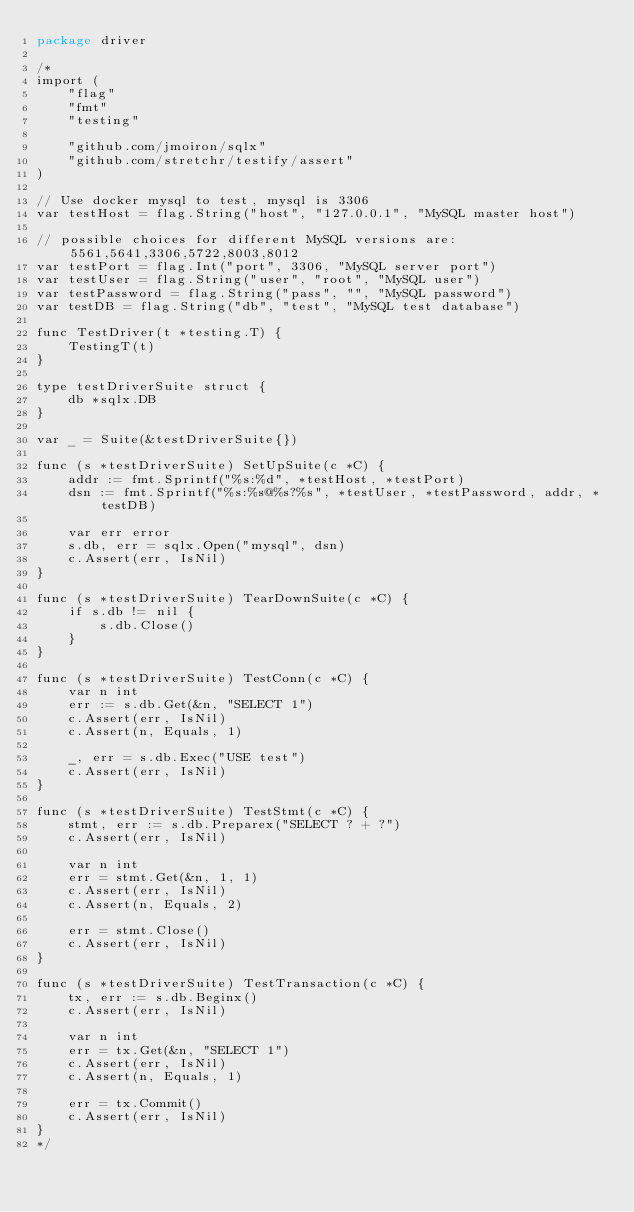Convert code to text. <code><loc_0><loc_0><loc_500><loc_500><_Go_>package driver

/*
import (
	"flag"
	"fmt"
	"testing"

	"github.com/jmoiron/sqlx"
	"github.com/stretchr/testify/assert"
)

// Use docker mysql to test, mysql is 3306
var testHost = flag.String("host", "127.0.0.1", "MySQL master host")

// possible choices for different MySQL versions are: 5561,5641,3306,5722,8003,8012
var testPort = flag.Int("port", 3306, "MySQL server port")
var testUser = flag.String("user", "root", "MySQL user")
var testPassword = flag.String("pass", "", "MySQL password")
var testDB = flag.String("db", "test", "MySQL test database")

func TestDriver(t *testing.T) {
	TestingT(t)
}

type testDriverSuite struct {
	db *sqlx.DB
}

var _ = Suite(&testDriverSuite{})

func (s *testDriverSuite) SetUpSuite(c *C) {
	addr := fmt.Sprintf("%s:%d", *testHost, *testPort)
	dsn := fmt.Sprintf("%s:%s@%s?%s", *testUser, *testPassword, addr, *testDB)

	var err error
	s.db, err = sqlx.Open("mysql", dsn)
	c.Assert(err, IsNil)
}

func (s *testDriverSuite) TearDownSuite(c *C) {
	if s.db != nil {
		s.db.Close()
	}
}

func (s *testDriverSuite) TestConn(c *C) {
	var n int
	err := s.db.Get(&n, "SELECT 1")
	c.Assert(err, IsNil)
	c.Assert(n, Equals, 1)

	_, err = s.db.Exec("USE test")
	c.Assert(err, IsNil)
}

func (s *testDriverSuite) TestStmt(c *C) {
	stmt, err := s.db.Preparex("SELECT ? + ?")
	c.Assert(err, IsNil)

	var n int
	err = stmt.Get(&n, 1, 1)
	c.Assert(err, IsNil)
	c.Assert(n, Equals, 2)

	err = stmt.Close()
	c.Assert(err, IsNil)
}

func (s *testDriverSuite) TestTransaction(c *C) {
	tx, err := s.db.Beginx()
	c.Assert(err, IsNil)

	var n int
	err = tx.Get(&n, "SELECT 1")
	c.Assert(err, IsNil)
	c.Assert(n, Equals, 1)

	err = tx.Commit()
	c.Assert(err, IsNil)
}
*/
</code> 